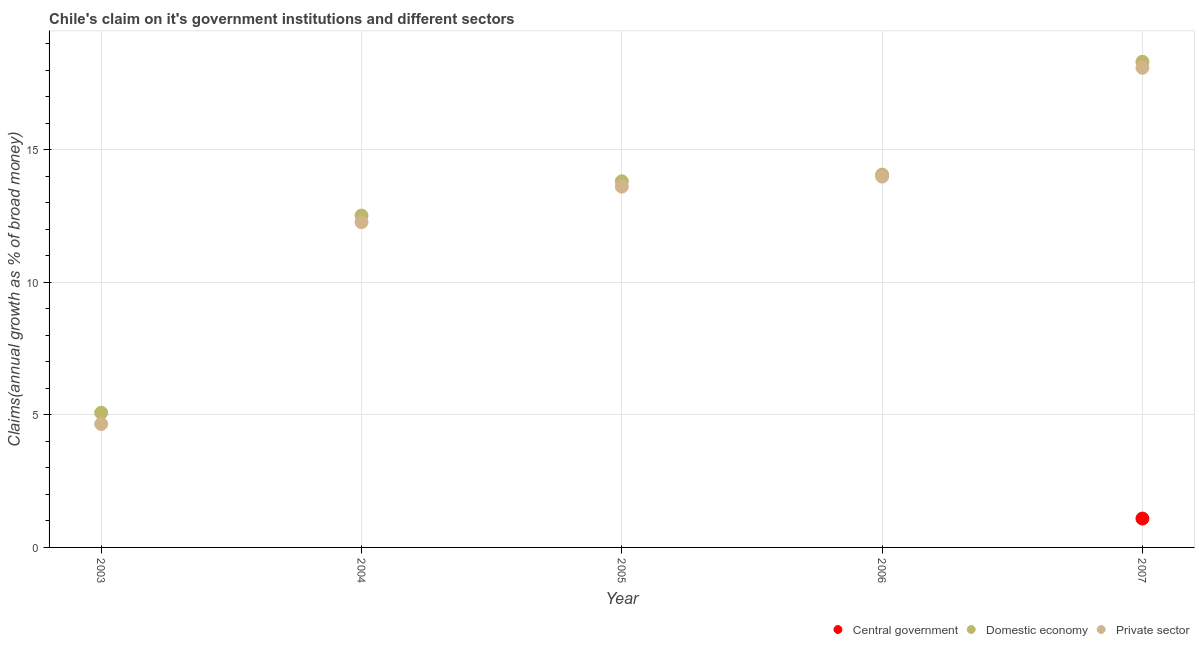How many different coloured dotlines are there?
Your answer should be very brief. 3. What is the percentage of claim on the private sector in 2007?
Your response must be concise. 18.09. Across all years, what is the maximum percentage of claim on the central government?
Provide a short and direct response. 1.09. Across all years, what is the minimum percentage of claim on the private sector?
Ensure brevity in your answer.  4.66. What is the total percentage of claim on the central government in the graph?
Make the answer very short. 1.09. What is the difference between the percentage of claim on the private sector in 2005 and that in 2006?
Your response must be concise. -0.38. What is the difference between the percentage of claim on the private sector in 2003 and the percentage of claim on the domestic economy in 2005?
Your answer should be compact. -9.15. What is the average percentage of claim on the central government per year?
Offer a very short reply. 0.22. In the year 2005, what is the difference between the percentage of claim on the private sector and percentage of claim on the domestic economy?
Provide a short and direct response. -0.2. What is the ratio of the percentage of claim on the private sector in 2003 to that in 2004?
Provide a short and direct response. 0.38. Is the percentage of claim on the private sector in 2004 less than that in 2006?
Offer a terse response. Yes. Is the difference between the percentage of claim on the private sector in 2003 and 2005 greater than the difference between the percentage of claim on the domestic economy in 2003 and 2005?
Provide a short and direct response. No. What is the difference between the highest and the second highest percentage of claim on the private sector?
Your response must be concise. 4.1. What is the difference between the highest and the lowest percentage of claim on the private sector?
Provide a short and direct response. 13.43. In how many years, is the percentage of claim on the central government greater than the average percentage of claim on the central government taken over all years?
Provide a short and direct response. 1. Is the sum of the percentage of claim on the domestic economy in 2003 and 2004 greater than the maximum percentage of claim on the central government across all years?
Give a very brief answer. Yes. Does the percentage of claim on the domestic economy monotonically increase over the years?
Make the answer very short. Yes. Is the percentage of claim on the private sector strictly less than the percentage of claim on the domestic economy over the years?
Provide a succinct answer. Yes. How many years are there in the graph?
Keep it short and to the point. 5. What is the difference between two consecutive major ticks on the Y-axis?
Ensure brevity in your answer.  5. What is the title of the graph?
Your answer should be very brief. Chile's claim on it's government institutions and different sectors. Does "Neonatal" appear as one of the legend labels in the graph?
Offer a terse response. No. What is the label or title of the X-axis?
Keep it short and to the point. Year. What is the label or title of the Y-axis?
Provide a succinct answer. Claims(annual growth as % of broad money). What is the Claims(annual growth as % of broad money) in Central government in 2003?
Ensure brevity in your answer.  0. What is the Claims(annual growth as % of broad money) of Domestic economy in 2003?
Provide a short and direct response. 5.08. What is the Claims(annual growth as % of broad money) in Private sector in 2003?
Make the answer very short. 4.66. What is the Claims(annual growth as % of broad money) in Domestic economy in 2004?
Your answer should be very brief. 12.51. What is the Claims(annual growth as % of broad money) of Private sector in 2004?
Make the answer very short. 12.26. What is the Claims(annual growth as % of broad money) in Domestic economy in 2005?
Keep it short and to the point. 13.81. What is the Claims(annual growth as % of broad money) of Private sector in 2005?
Make the answer very short. 13.6. What is the Claims(annual growth as % of broad money) in Domestic economy in 2006?
Provide a succinct answer. 14.06. What is the Claims(annual growth as % of broad money) in Private sector in 2006?
Make the answer very short. 13.98. What is the Claims(annual growth as % of broad money) of Central government in 2007?
Give a very brief answer. 1.09. What is the Claims(annual growth as % of broad money) of Domestic economy in 2007?
Your answer should be compact. 18.31. What is the Claims(annual growth as % of broad money) of Private sector in 2007?
Keep it short and to the point. 18.09. Across all years, what is the maximum Claims(annual growth as % of broad money) of Central government?
Give a very brief answer. 1.09. Across all years, what is the maximum Claims(annual growth as % of broad money) of Domestic economy?
Your response must be concise. 18.31. Across all years, what is the maximum Claims(annual growth as % of broad money) of Private sector?
Your response must be concise. 18.09. Across all years, what is the minimum Claims(annual growth as % of broad money) of Domestic economy?
Provide a succinct answer. 5.08. Across all years, what is the minimum Claims(annual growth as % of broad money) in Private sector?
Provide a short and direct response. 4.66. What is the total Claims(annual growth as % of broad money) of Central government in the graph?
Your answer should be very brief. 1.09. What is the total Claims(annual growth as % of broad money) of Domestic economy in the graph?
Offer a terse response. 63.77. What is the total Claims(annual growth as % of broad money) in Private sector in the graph?
Offer a very short reply. 62.59. What is the difference between the Claims(annual growth as % of broad money) in Domestic economy in 2003 and that in 2004?
Provide a succinct answer. -7.43. What is the difference between the Claims(annual growth as % of broad money) in Private sector in 2003 and that in 2004?
Your answer should be very brief. -7.61. What is the difference between the Claims(annual growth as % of broad money) of Domestic economy in 2003 and that in 2005?
Provide a succinct answer. -8.73. What is the difference between the Claims(annual growth as % of broad money) of Private sector in 2003 and that in 2005?
Provide a succinct answer. -8.95. What is the difference between the Claims(annual growth as % of broad money) of Domestic economy in 2003 and that in 2006?
Provide a succinct answer. -8.98. What is the difference between the Claims(annual growth as % of broad money) in Private sector in 2003 and that in 2006?
Your answer should be very brief. -9.33. What is the difference between the Claims(annual growth as % of broad money) of Domestic economy in 2003 and that in 2007?
Make the answer very short. -13.23. What is the difference between the Claims(annual growth as % of broad money) of Private sector in 2003 and that in 2007?
Your response must be concise. -13.43. What is the difference between the Claims(annual growth as % of broad money) of Domestic economy in 2004 and that in 2005?
Keep it short and to the point. -1.29. What is the difference between the Claims(annual growth as % of broad money) of Private sector in 2004 and that in 2005?
Provide a short and direct response. -1.34. What is the difference between the Claims(annual growth as % of broad money) of Domestic economy in 2004 and that in 2006?
Your answer should be compact. -1.54. What is the difference between the Claims(annual growth as % of broad money) of Private sector in 2004 and that in 2006?
Keep it short and to the point. -1.72. What is the difference between the Claims(annual growth as % of broad money) of Domestic economy in 2004 and that in 2007?
Your answer should be very brief. -5.8. What is the difference between the Claims(annual growth as % of broad money) in Private sector in 2004 and that in 2007?
Your answer should be compact. -5.82. What is the difference between the Claims(annual growth as % of broad money) in Domestic economy in 2005 and that in 2006?
Your answer should be very brief. -0.25. What is the difference between the Claims(annual growth as % of broad money) in Private sector in 2005 and that in 2006?
Your response must be concise. -0.38. What is the difference between the Claims(annual growth as % of broad money) of Domestic economy in 2005 and that in 2007?
Make the answer very short. -4.51. What is the difference between the Claims(annual growth as % of broad money) of Private sector in 2005 and that in 2007?
Offer a terse response. -4.48. What is the difference between the Claims(annual growth as % of broad money) in Domestic economy in 2006 and that in 2007?
Offer a terse response. -4.25. What is the difference between the Claims(annual growth as % of broad money) of Private sector in 2006 and that in 2007?
Provide a short and direct response. -4.1. What is the difference between the Claims(annual growth as % of broad money) of Domestic economy in 2003 and the Claims(annual growth as % of broad money) of Private sector in 2004?
Your answer should be compact. -7.18. What is the difference between the Claims(annual growth as % of broad money) of Domestic economy in 2003 and the Claims(annual growth as % of broad money) of Private sector in 2005?
Keep it short and to the point. -8.52. What is the difference between the Claims(annual growth as % of broad money) in Domestic economy in 2003 and the Claims(annual growth as % of broad money) in Private sector in 2006?
Your answer should be very brief. -8.9. What is the difference between the Claims(annual growth as % of broad money) in Domestic economy in 2003 and the Claims(annual growth as % of broad money) in Private sector in 2007?
Ensure brevity in your answer.  -13.01. What is the difference between the Claims(annual growth as % of broad money) in Domestic economy in 2004 and the Claims(annual growth as % of broad money) in Private sector in 2005?
Offer a terse response. -1.09. What is the difference between the Claims(annual growth as % of broad money) in Domestic economy in 2004 and the Claims(annual growth as % of broad money) in Private sector in 2006?
Provide a short and direct response. -1.47. What is the difference between the Claims(annual growth as % of broad money) in Domestic economy in 2004 and the Claims(annual growth as % of broad money) in Private sector in 2007?
Make the answer very short. -5.57. What is the difference between the Claims(annual growth as % of broad money) in Domestic economy in 2005 and the Claims(annual growth as % of broad money) in Private sector in 2006?
Give a very brief answer. -0.18. What is the difference between the Claims(annual growth as % of broad money) in Domestic economy in 2005 and the Claims(annual growth as % of broad money) in Private sector in 2007?
Keep it short and to the point. -4.28. What is the difference between the Claims(annual growth as % of broad money) of Domestic economy in 2006 and the Claims(annual growth as % of broad money) of Private sector in 2007?
Your response must be concise. -4.03. What is the average Claims(annual growth as % of broad money) in Central government per year?
Provide a short and direct response. 0.22. What is the average Claims(annual growth as % of broad money) in Domestic economy per year?
Keep it short and to the point. 12.75. What is the average Claims(annual growth as % of broad money) of Private sector per year?
Offer a terse response. 12.52. In the year 2003, what is the difference between the Claims(annual growth as % of broad money) of Domestic economy and Claims(annual growth as % of broad money) of Private sector?
Offer a very short reply. 0.42. In the year 2004, what is the difference between the Claims(annual growth as % of broad money) in Domestic economy and Claims(annual growth as % of broad money) in Private sector?
Give a very brief answer. 0.25. In the year 2005, what is the difference between the Claims(annual growth as % of broad money) of Domestic economy and Claims(annual growth as % of broad money) of Private sector?
Ensure brevity in your answer.  0.2. In the year 2006, what is the difference between the Claims(annual growth as % of broad money) of Domestic economy and Claims(annual growth as % of broad money) of Private sector?
Your response must be concise. 0.07. In the year 2007, what is the difference between the Claims(annual growth as % of broad money) in Central government and Claims(annual growth as % of broad money) in Domestic economy?
Your answer should be very brief. -17.22. In the year 2007, what is the difference between the Claims(annual growth as % of broad money) in Central government and Claims(annual growth as % of broad money) in Private sector?
Offer a terse response. -17. In the year 2007, what is the difference between the Claims(annual growth as % of broad money) in Domestic economy and Claims(annual growth as % of broad money) in Private sector?
Offer a very short reply. 0.23. What is the ratio of the Claims(annual growth as % of broad money) of Domestic economy in 2003 to that in 2004?
Your answer should be compact. 0.41. What is the ratio of the Claims(annual growth as % of broad money) in Private sector in 2003 to that in 2004?
Give a very brief answer. 0.38. What is the ratio of the Claims(annual growth as % of broad money) in Domestic economy in 2003 to that in 2005?
Your response must be concise. 0.37. What is the ratio of the Claims(annual growth as % of broad money) of Private sector in 2003 to that in 2005?
Keep it short and to the point. 0.34. What is the ratio of the Claims(annual growth as % of broad money) of Domestic economy in 2003 to that in 2006?
Keep it short and to the point. 0.36. What is the ratio of the Claims(annual growth as % of broad money) of Private sector in 2003 to that in 2006?
Ensure brevity in your answer.  0.33. What is the ratio of the Claims(annual growth as % of broad money) of Domestic economy in 2003 to that in 2007?
Provide a short and direct response. 0.28. What is the ratio of the Claims(annual growth as % of broad money) in Private sector in 2003 to that in 2007?
Provide a short and direct response. 0.26. What is the ratio of the Claims(annual growth as % of broad money) of Domestic economy in 2004 to that in 2005?
Your response must be concise. 0.91. What is the ratio of the Claims(annual growth as % of broad money) of Private sector in 2004 to that in 2005?
Keep it short and to the point. 0.9. What is the ratio of the Claims(annual growth as % of broad money) of Domestic economy in 2004 to that in 2006?
Your response must be concise. 0.89. What is the ratio of the Claims(annual growth as % of broad money) of Private sector in 2004 to that in 2006?
Provide a succinct answer. 0.88. What is the ratio of the Claims(annual growth as % of broad money) in Domestic economy in 2004 to that in 2007?
Offer a terse response. 0.68. What is the ratio of the Claims(annual growth as % of broad money) in Private sector in 2004 to that in 2007?
Provide a succinct answer. 0.68. What is the ratio of the Claims(annual growth as % of broad money) of Domestic economy in 2005 to that in 2006?
Provide a short and direct response. 0.98. What is the ratio of the Claims(annual growth as % of broad money) in Private sector in 2005 to that in 2006?
Keep it short and to the point. 0.97. What is the ratio of the Claims(annual growth as % of broad money) of Domestic economy in 2005 to that in 2007?
Give a very brief answer. 0.75. What is the ratio of the Claims(annual growth as % of broad money) of Private sector in 2005 to that in 2007?
Provide a succinct answer. 0.75. What is the ratio of the Claims(annual growth as % of broad money) in Domestic economy in 2006 to that in 2007?
Provide a short and direct response. 0.77. What is the ratio of the Claims(annual growth as % of broad money) of Private sector in 2006 to that in 2007?
Provide a succinct answer. 0.77. What is the difference between the highest and the second highest Claims(annual growth as % of broad money) in Domestic economy?
Give a very brief answer. 4.25. What is the difference between the highest and the second highest Claims(annual growth as % of broad money) of Private sector?
Make the answer very short. 4.1. What is the difference between the highest and the lowest Claims(annual growth as % of broad money) of Central government?
Your answer should be very brief. 1.09. What is the difference between the highest and the lowest Claims(annual growth as % of broad money) of Domestic economy?
Keep it short and to the point. 13.23. What is the difference between the highest and the lowest Claims(annual growth as % of broad money) of Private sector?
Offer a terse response. 13.43. 